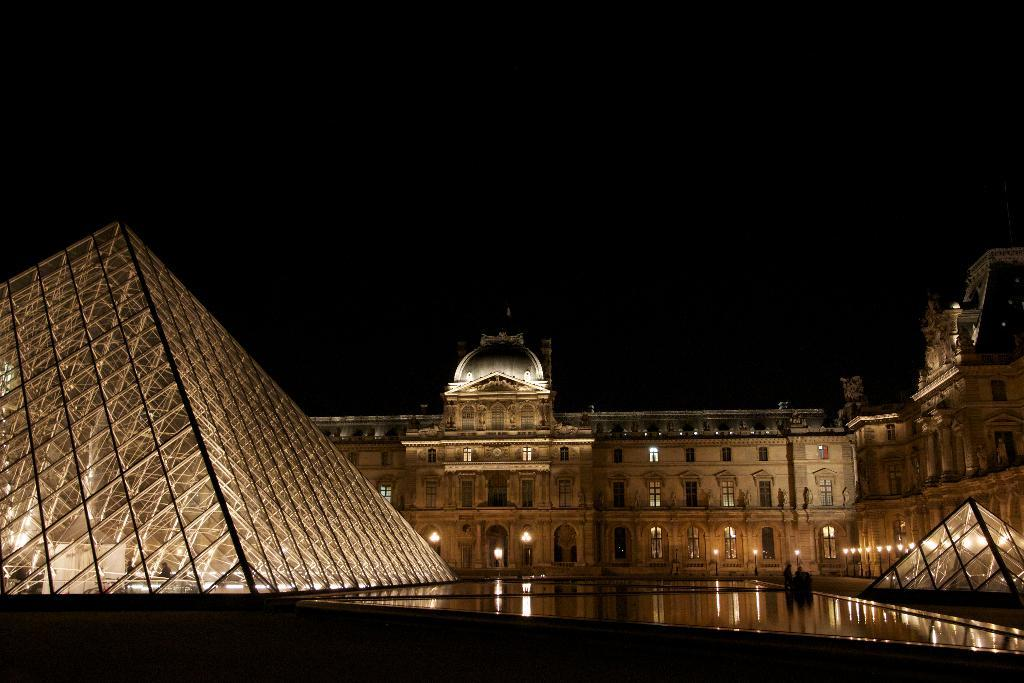What type of structures can be seen in the image? There are buildings in the image. Are there any specific features of the buildings that can be observed? Yes, there is a glass pyramid construction in the image. What else is visible in the image besides the buildings? There are lights visible in the image. How many cherries are on top of the glass pyramid in the image? There are no cherries present in the image. What type of match is being played in the image? There is no match or any indication of a game being played in the image. 